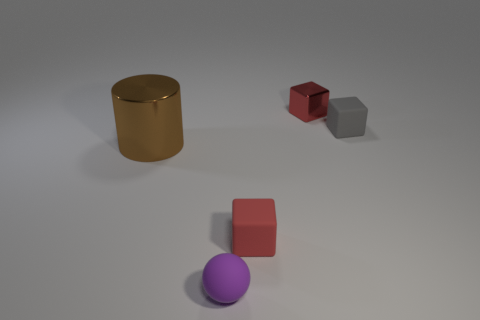Add 2 purple rubber things. How many objects exist? 7 Subtract all spheres. How many objects are left? 4 Subtract all big cyan shiny objects. Subtract all gray objects. How many objects are left? 4 Add 5 small red matte objects. How many small red matte objects are left? 6 Add 1 small rubber spheres. How many small rubber spheres exist? 2 Subtract 0 red cylinders. How many objects are left? 5 